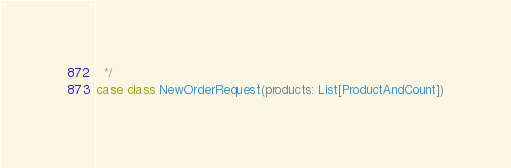Convert code to text. <code><loc_0><loc_0><loc_500><loc_500><_Scala_>  */
case class NewOrderRequest(products: List[ProductAndCount])
</code> 